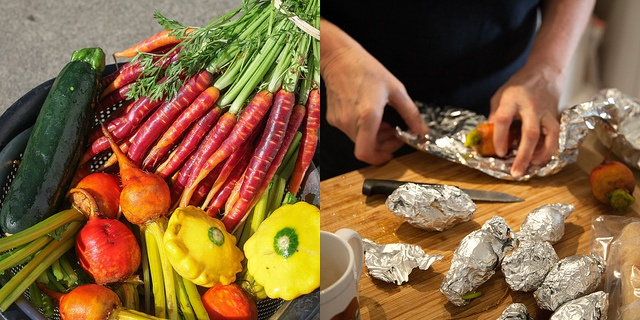Describe the objects in this image and their specific colors. I can see people in gray, black, brown, and tan tones, dining table in gray, maroon, olive, and orange tones, carrot in gray, brown, maroon, salmon, and black tones, cup in gray, olive, and tan tones, and knife in gray and black tones in this image. 